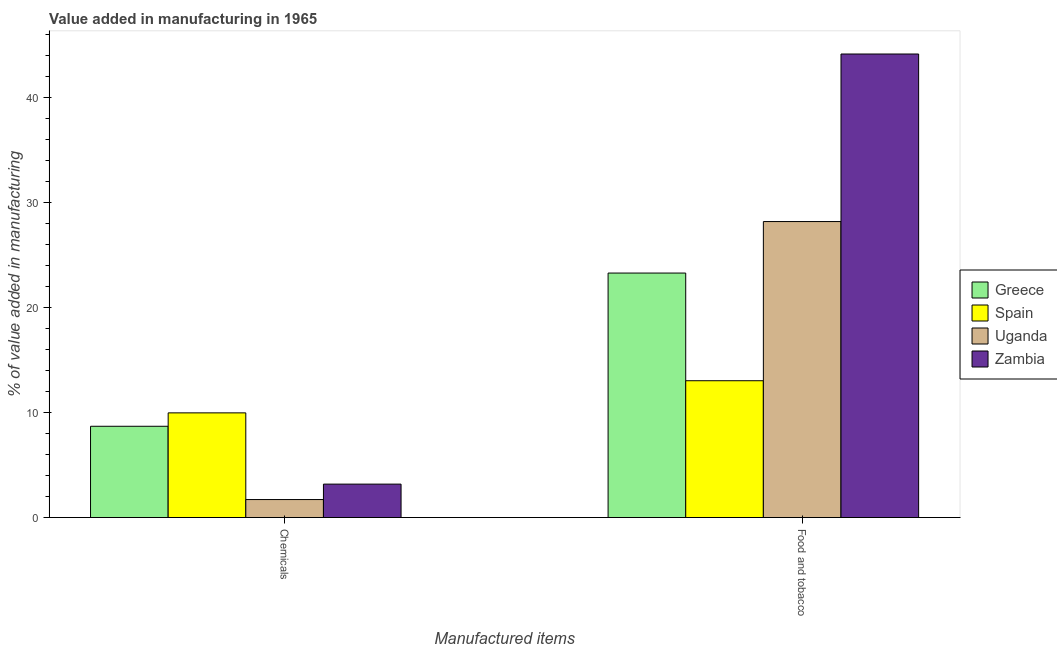How many different coloured bars are there?
Make the answer very short. 4. Are the number of bars per tick equal to the number of legend labels?
Give a very brief answer. Yes. Are the number of bars on each tick of the X-axis equal?
Make the answer very short. Yes. How many bars are there on the 2nd tick from the left?
Offer a very short reply. 4. How many bars are there on the 2nd tick from the right?
Ensure brevity in your answer.  4. What is the label of the 2nd group of bars from the left?
Provide a short and direct response. Food and tobacco. What is the value added by  manufacturing chemicals in Greece?
Provide a short and direct response. 8.7. Across all countries, what is the maximum value added by manufacturing food and tobacco?
Your answer should be compact. 44.19. Across all countries, what is the minimum value added by manufacturing food and tobacco?
Ensure brevity in your answer.  13.04. In which country was the value added by manufacturing food and tobacco maximum?
Keep it short and to the point. Zambia. What is the total value added by  manufacturing chemicals in the graph?
Keep it short and to the point. 23.58. What is the difference between the value added by  manufacturing chemicals in Zambia and that in Uganda?
Your answer should be compact. 1.47. What is the difference between the value added by  manufacturing chemicals in Zambia and the value added by manufacturing food and tobacco in Greece?
Offer a terse response. -20.12. What is the average value added by manufacturing food and tobacco per country?
Make the answer very short. 27.19. What is the difference between the value added by  manufacturing chemicals and value added by manufacturing food and tobacco in Spain?
Make the answer very short. -3.06. What is the ratio of the value added by  manufacturing chemicals in Uganda to that in Zambia?
Your answer should be very brief. 0.54. Is the value added by manufacturing food and tobacco in Uganda less than that in Spain?
Offer a very short reply. No. In how many countries, is the value added by manufacturing food and tobacco greater than the average value added by manufacturing food and tobacco taken over all countries?
Your answer should be compact. 2. How many bars are there?
Offer a terse response. 8. Are all the bars in the graph horizontal?
Your answer should be very brief. No. How many countries are there in the graph?
Make the answer very short. 4. Does the graph contain grids?
Give a very brief answer. No. What is the title of the graph?
Your answer should be very brief. Value added in manufacturing in 1965. What is the label or title of the X-axis?
Offer a very short reply. Manufactured items. What is the label or title of the Y-axis?
Provide a succinct answer. % of value added in manufacturing. What is the % of value added in manufacturing of Greece in Chemicals?
Offer a very short reply. 8.7. What is the % of value added in manufacturing in Spain in Chemicals?
Make the answer very short. 9.98. What is the % of value added in manufacturing of Uganda in Chemicals?
Provide a short and direct response. 1.72. What is the % of value added in manufacturing of Zambia in Chemicals?
Your answer should be very brief. 3.19. What is the % of value added in manufacturing of Greece in Food and tobacco?
Your answer should be very brief. 23.31. What is the % of value added in manufacturing in Spain in Food and tobacco?
Offer a very short reply. 13.04. What is the % of value added in manufacturing in Uganda in Food and tobacco?
Ensure brevity in your answer.  28.22. What is the % of value added in manufacturing of Zambia in Food and tobacco?
Your response must be concise. 44.19. Across all Manufactured items, what is the maximum % of value added in manufacturing in Greece?
Offer a terse response. 23.31. Across all Manufactured items, what is the maximum % of value added in manufacturing in Spain?
Offer a terse response. 13.04. Across all Manufactured items, what is the maximum % of value added in manufacturing in Uganda?
Your answer should be compact. 28.22. Across all Manufactured items, what is the maximum % of value added in manufacturing in Zambia?
Keep it short and to the point. 44.19. Across all Manufactured items, what is the minimum % of value added in manufacturing of Greece?
Provide a succinct answer. 8.7. Across all Manufactured items, what is the minimum % of value added in manufacturing in Spain?
Ensure brevity in your answer.  9.98. Across all Manufactured items, what is the minimum % of value added in manufacturing of Uganda?
Provide a succinct answer. 1.72. Across all Manufactured items, what is the minimum % of value added in manufacturing in Zambia?
Make the answer very short. 3.19. What is the total % of value added in manufacturing of Greece in the graph?
Your answer should be compact. 32.01. What is the total % of value added in manufacturing of Spain in the graph?
Give a very brief answer. 23.02. What is the total % of value added in manufacturing of Uganda in the graph?
Offer a terse response. 29.93. What is the total % of value added in manufacturing of Zambia in the graph?
Offer a terse response. 47.37. What is the difference between the % of value added in manufacturing of Greece in Chemicals and that in Food and tobacco?
Your answer should be compact. -14.61. What is the difference between the % of value added in manufacturing of Spain in Chemicals and that in Food and tobacco?
Provide a succinct answer. -3.06. What is the difference between the % of value added in manufacturing in Uganda in Chemicals and that in Food and tobacco?
Provide a succinct answer. -26.5. What is the difference between the % of value added in manufacturing of Zambia in Chemicals and that in Food and tobacco?
Provide a succinct answer. -41. What is the difference between the % of value added in manufacturing of Greece in Chemicals and the % of value added in manufacturing of Spain in Food and tobacco?
Provide a succinct answer. -4.34. What is the difference between the % of value added in manufacturing in Greece in Chemicals and the % of value added in manufacturing in Uganda in Food and tobacco?
Your answer should be compact. -19.51. What is the difference between the % of value added in manufacturing in Greece in Chemicals and the % of value added in manufacturing in Zambia in Food and tobacco?
Ensure brevity in your answer.  -35.49. What is the difference between the % of value added in manufacturing in Spain in Chemicals and the % of value added in manufacturing in Uganda in Food and tobacco?
Keep it short and to the point. -18.24. What is the difference between the % of value added in manufacturing of Spain in Chemicals and the % of value added in manufacturing of Zambia in Food and tobacco?
Your response must be concise. -34.21. What is the difference between the % of value added in manufacturing in Uganda in Chemicals and the % of value added in manufacturing in Zambia in Food and tobacco?
Your answer should be very brief. -42.47. What is the average % of value added in manufacturing in Greece per Manufactured items?
Ensure brevity in your answer.  16. What is the average % of value added in manufacturing of Spain per Manufactured items?
Give a very brief answer. 11.51. What is the average % of value added in manufacturing in Uganda per Manufactured items?
Your response must be concise. 14.97. What is the average % of value added in manufacturing of Zambia per Manufactured items?
Your answer should be very brief. 23.69. What is the difference between the % of value added in manufacturing of Greece and % of value added in manufacturing of Spain in Chemicals?
Offer a very short reply. -1.28. What is the difference between the % of value added in manufacturing in Greece and % of value added in manufacturing in Uganda in Chemicals?
Keep it short and to the point. 6.98. What is the difference between the % of value added in manufacturing in Greece and % of value added in manufacturing in Zambia in Chemicals?
Ensure brevity in your answer.  5.51. What is the difference between the % of value added in manufacturing in Spain and % of value added in manufacturing in Uganda in Chemicals?
Offer a terse response. 8.26. What is the difference between the % of value added in manufacturing of Spain and % of value added in manufacturing of Zambia in Chemicals?
Make the answer very short. 6.79. What is the difference between the % of value added in manufacturing of Uganda and % of value added in manufacturing of Zambia in Chemicals?
Provide a succinct answer. -1.47. What is the difference between the % of value added in manufacturing in Greece and % of value added in manufacturing in Spain in Food and tobacco?
Ensure brevity in your answer.  10.26. What is the difference between the % of value added in manufacturing of Greece and % of value added in manufacturing of Uganda in Food and tobacco?
Give a very brief answer. -4.91. What is the difference between the % of value added in manufacturing in Greece and % of value added in manufacturing in Zambia in Food and tobacco?
Offer a terse response. -20.88. What is the difference between the % of value added in manufacturing in Spain and % of value added in manufacturing in Uganda in Food and tobacco?
Provide a succinct answer. -15.17. What is the difference between the % of value added in manufacturing in Spain and % of value added in manufacturing in Zambia in Food and tobacco?
Offer a terse response. -31.14. What is the difference between the % of value added in manufacturing of Uganda and % of value added in manufacturing of Zambia in Food and tobacco?
Provide a short and direct response. -15.97. What is the ratio of the % of value added in manufacturing of Greece in Chemicals to that in Food and tobacco?
Your answer should be compact. 0.37. What is the ratio of the % of value added in manufacturing of Spain in Chemicals to that in Food and tobacco?
Your answer should be compact. 0.77. What is the ratio of the % of value added in manufacturing in Uganda in Chemicals to that in Food and tobacco?
Ensure brevity in your answer.  0.06. What is the ratio of the % of value added in manufacturing in Zambia in Chemicals to that in Food and tobacco?
Offer a terse response. 0.07. What is the difference between the highest and the second highest % of value added in manufacturing in Greece?
Offer a very short reply. 14.61. What is the difference between the highest and the second highest % of value added in manufacturing in Spain?
Your response must be concise. 3.06. What is the difference between the highest and the second highest % of value added in manufacturing in Uganda?
Offer a very short reply. 26.5. What is the difference between the highest and the second highest % of value added in manufacturing of Zambia?
Your answer should be compact. 41. What is the difference between the highest and the lowest % of value added in manufacturing in Greece?
Your answer should be very brief. 14.61. What is the difference between the highest and the lowest % of value added in manufacturing of Spain?
Provide a short and direct response. 3.06. What is the difference between the highest and the lowest % of value added in manufacturing in Uganda?
Your answer should be very brief. 26.5. What is the difference between the highest and the lowest % of value added in manufacturing in Zambia?
Keep it short and to the point. 41. 